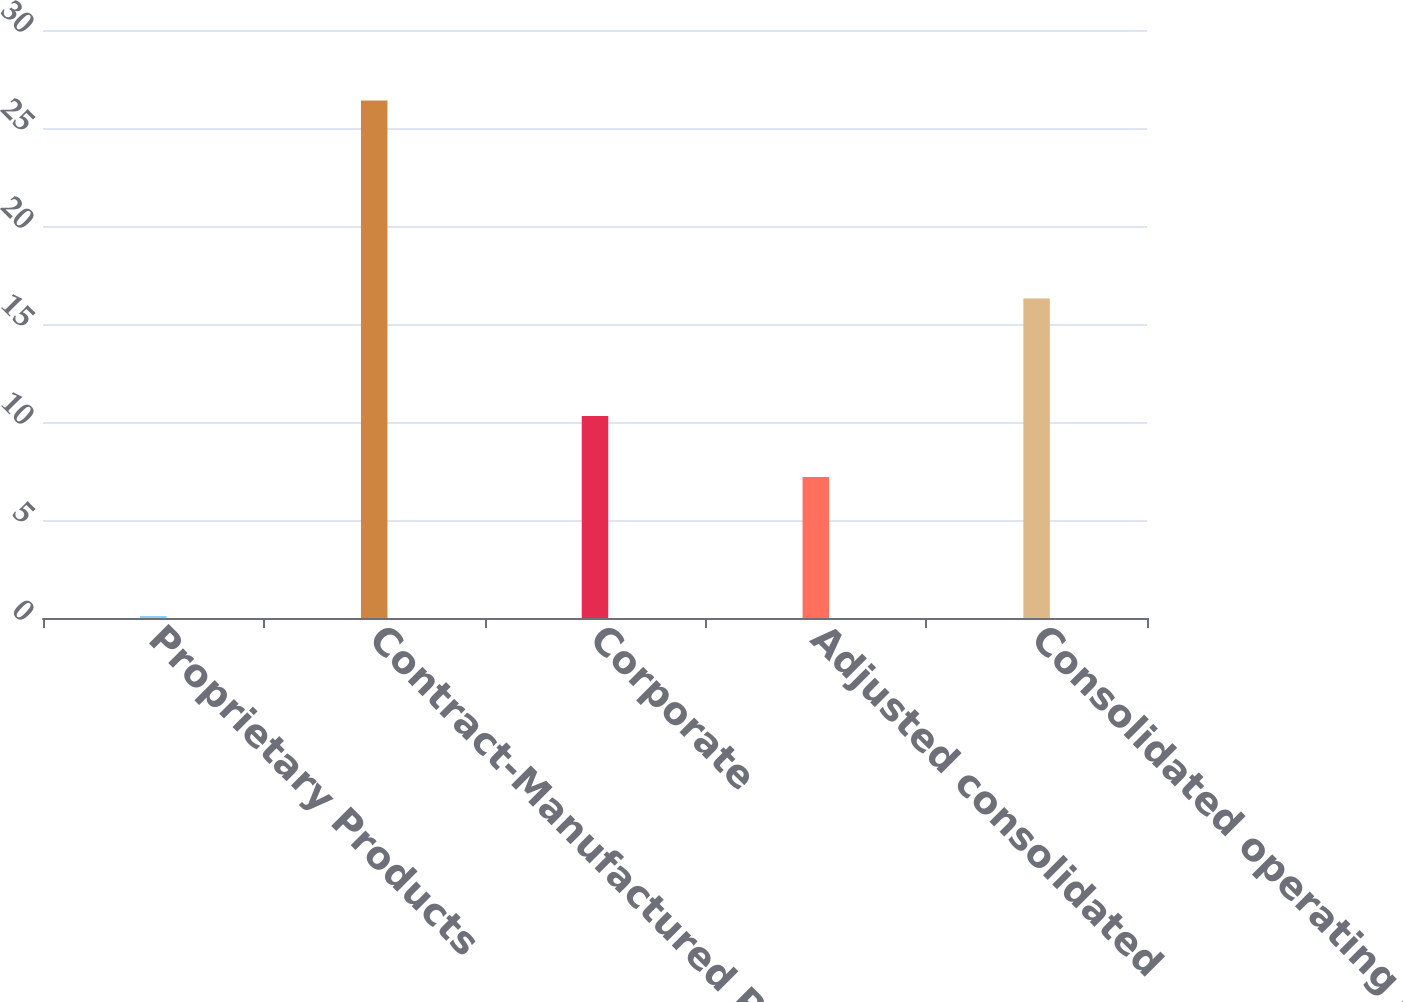Convert chart to OTSL. <chart><loc_0><loc_0><loc_500><loc_500><bar_chart><fcel>Proprietary Products<fcel>Contract-Manufactured Products<fcel>Corporate<fcel>Adjusted consolidated<fcel>Consolidated operating profit<nl><fcel>0.1<fcel>26.4<fcel>10.3<fcel>7.2<fcel>16.3<nl></chart> 